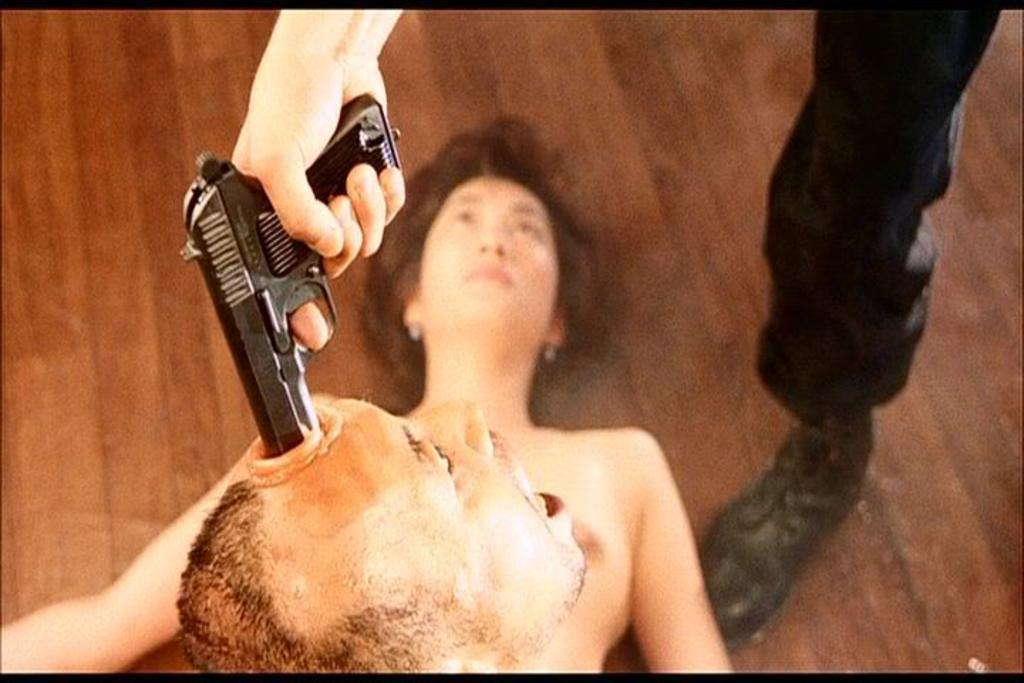What body part is visible in the image? There is a person's leg in the image. What object is being held by a hand in the image? There is a hand holding a gun in the image. What facial feature is visible at the bottom of the image? There is a person's face at the bottom of the image. What position is the other person in the image? There is another person laying down in the image. What year is depicted in the image? There is no indication of a specific year in the image. What type of bed is the person laying on in the image? There is no bed present in the image; the person is laying on the ground or another surface. Is there a locket visible in the image? There is no locket present in the image. 